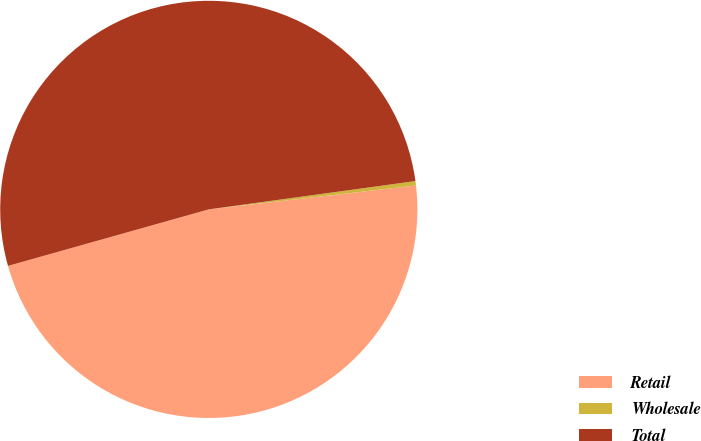<chart> <loc_0><loc_0><loc_500><loc_500><pie_chart><fcel>Retail<fcel>Wholesale<fcel>Total<nl><fcel>47.46%<fcel>0.34%<fcel>52.2%<nl></chart> 